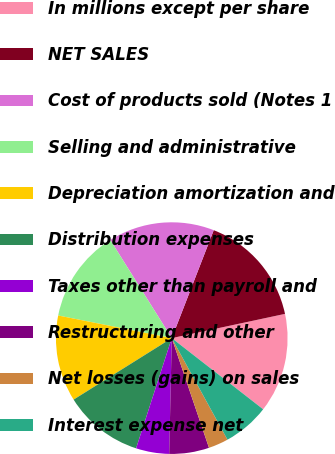<chart> <loc_0><loc_0><loc_500><loc_500><pie_chart><fcel>In millions except per share<fcel>NET SALES<fcel>Cost of products sold (Notes 1<fcel>Selling and administrative<fcel>Depreciation amortization and<fcel>Distribution expenses<fcel>Taxes other than payroll and<fcel>Restructuring and other<fcel>Net losses (gains) on sales<fcel>Interest expense net<nl><fcel>13.89%<fcel>15.74%<fcel>14.81%<fcel>12.96%<fcel>12.04%<fcel>11.11%<fcel>4.63%<fcel>5.56%<fcel>2.78%<fcel>6.48%<nl></chart> 